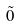<formula> <loc_0><loc_0><loc_500><loc_500>\tilde { 0 }</formula> 